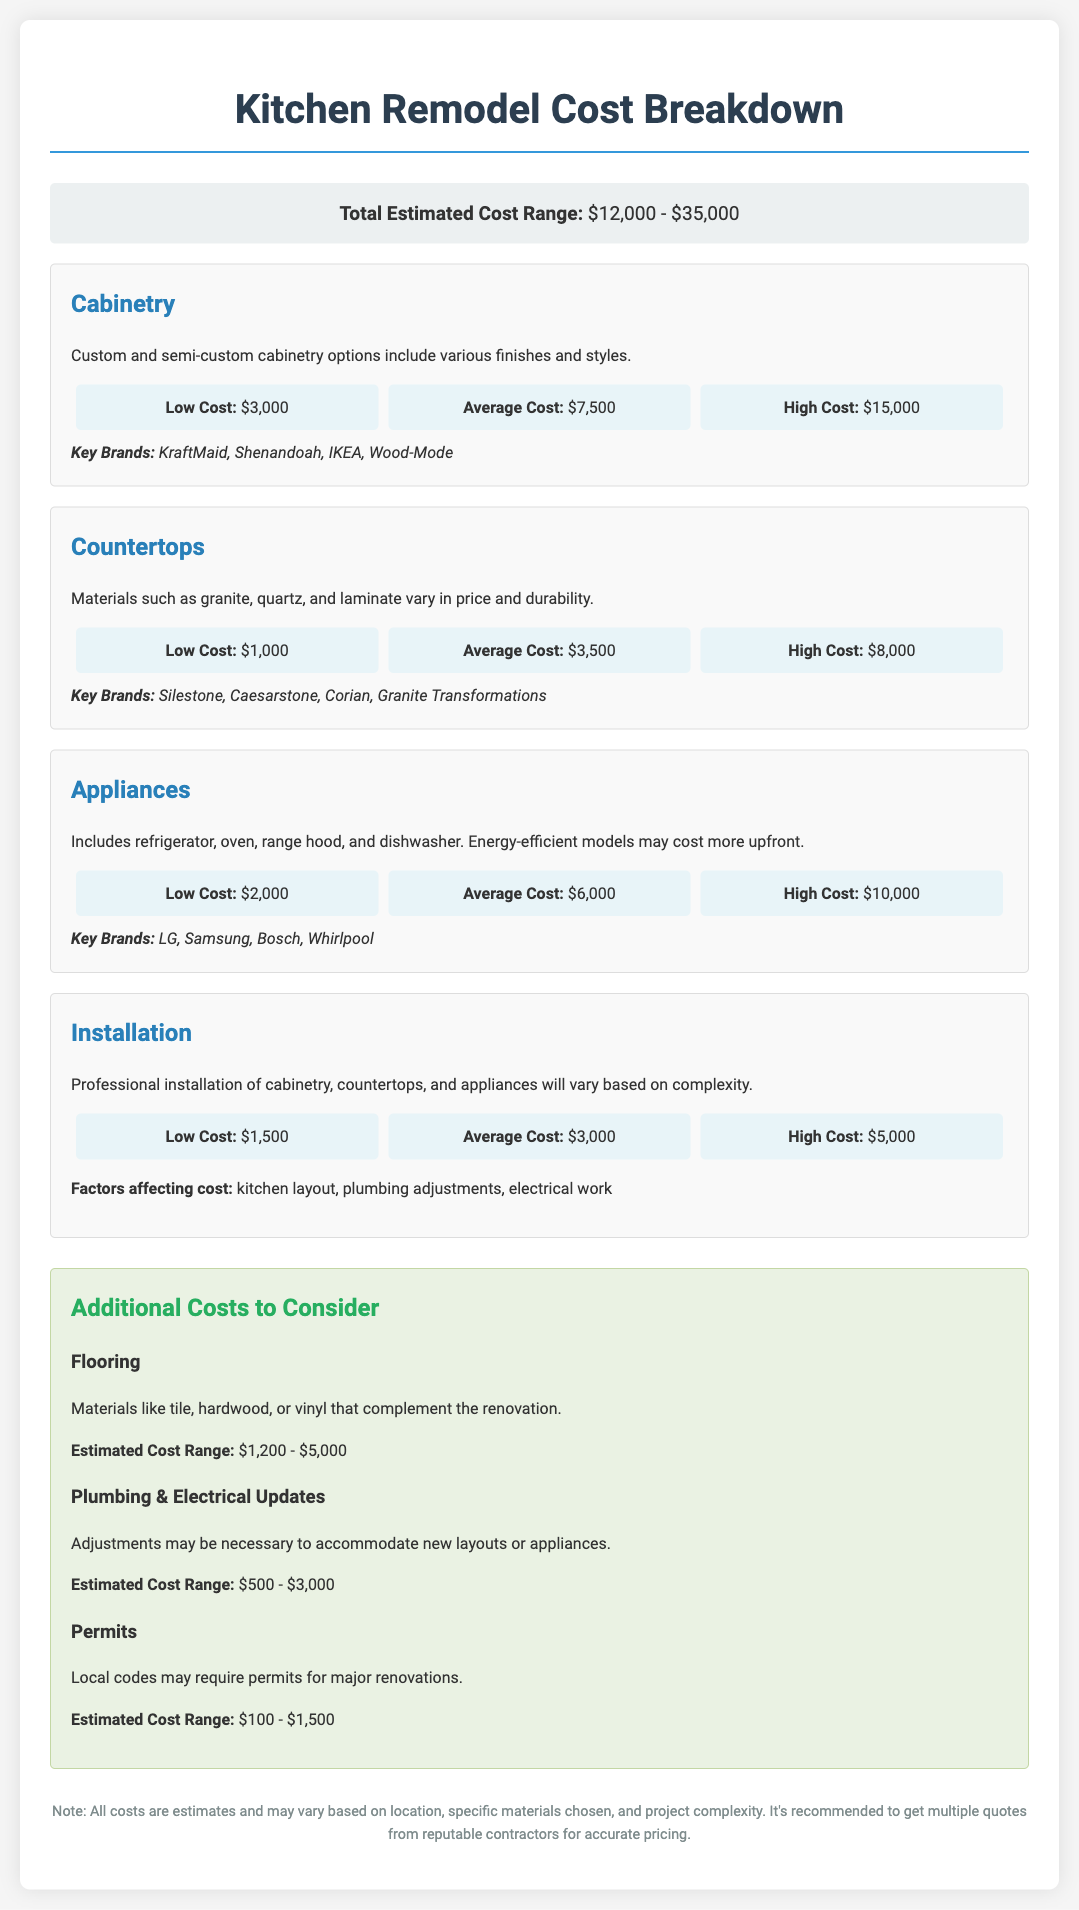What is the total estimated cost range for the kitchen remodel? The total estimated cost range is provided at the beginning of the document, indicating the minimum and maximum potential costs.
Answer: $12,000 - $35,000 What is the low cost for cabinetry? The low cost for cabinetry is specified under the cabinetry section as the minimum expense for this component.
Answer: $3,000 Which brand is mentioned for countertops? The document lists key brands for countertops; this is a specific retrieval of information regarding a component's recommended brands.
Answer: Silestone What is the average cost for appliances? The average cost for appliances is noted as the typical expense one might expect when including this component in a kitchen remodel.
Answer: $6,000 How much are plumbing and electrical updates estimated to cost? This cost range appears in the additional costs section, indicating financial expectations for necessary updates.
Answer: $500 - $3,000 Which component has the highest low cost? This question requires reasoning based on comparing low costs across components detailed in the document.
Answer: Cabinetry What is one factor affecting installation costs? Installation costs can vary based on multiple factors identified in the installation section; this question requires a specific detail.
Answer: kitchen layout What is the estimated cost range for flooring? This is an information retrieval question regarding another component mentioned in the additional costs section.
Answer: $1,200 - $5,000 What is the high cost for countertops? The high cost for countertops is presented within the cost details of that particular component, indicating the maximum expense.
Answer: $8,000 